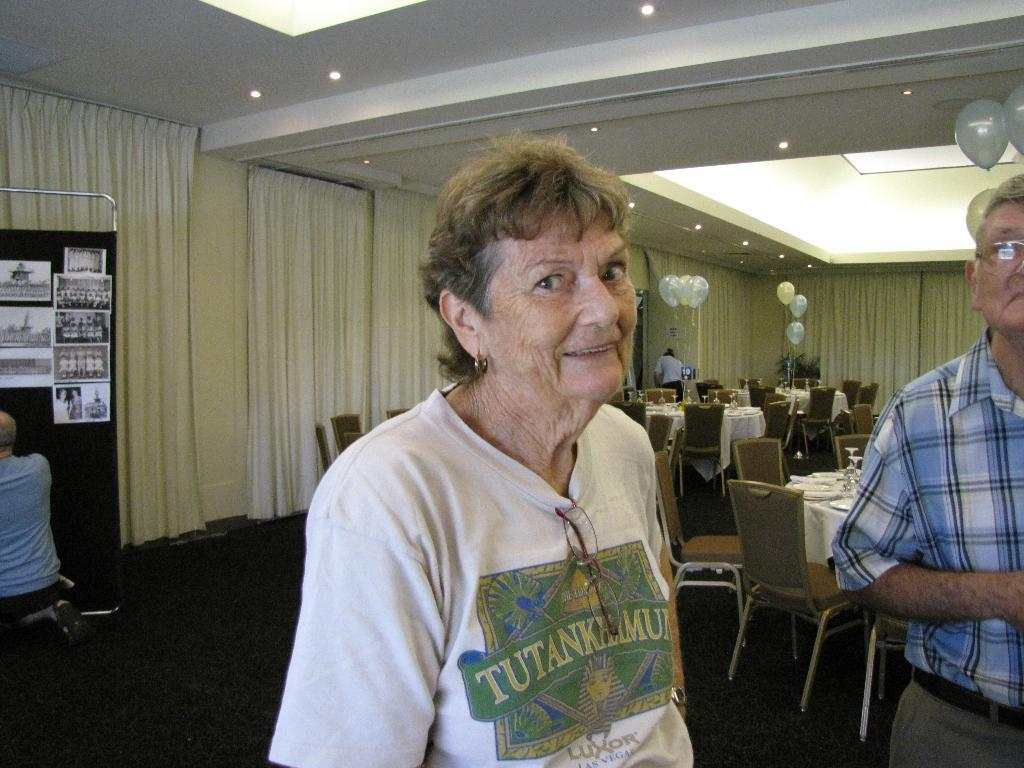Who are the people in the image? There is a woman and a man in the image. What is the woman doing in the image? The woman is smiling in the image. What can be seen in the background of the image? There are chairs, tables, and balloons in the background of the image. What type of curve can be seen on the bomb in the image? There is no bomb present in the image, so there is no curve to describe. 